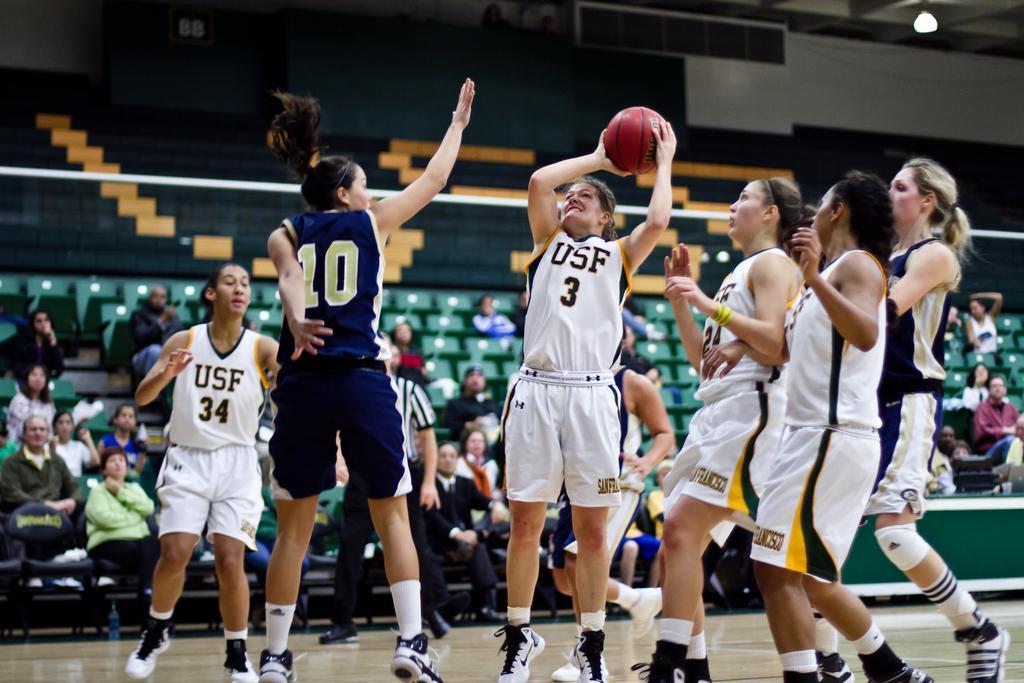In one or two sentences, can you explain what this image depicts? In the image there are a group of women playing basketball in a stadium and behind them the spectators are watching the game. 